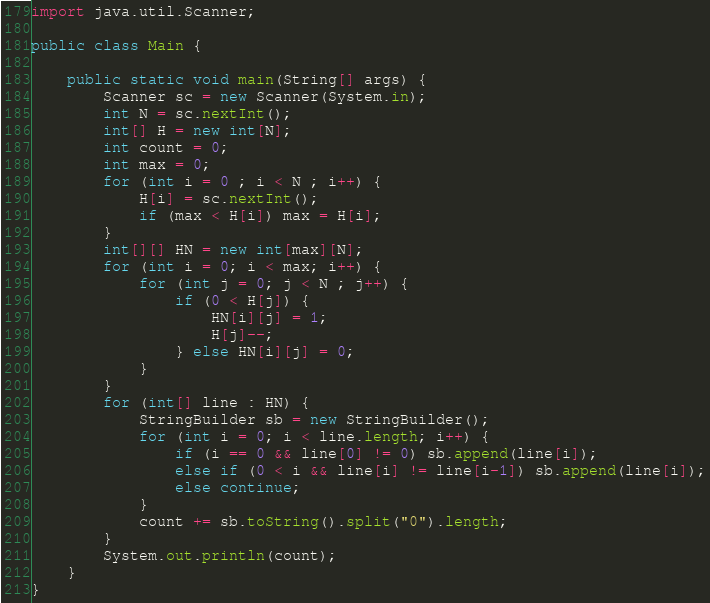<code> <loc_0><loc_0><loc_500><loc_500><_Java_>
import java.util.Scanner;

public class Main {
    
    public static void main(String[] args) {
        Scanner sc = new Scanner(System.in);
        int N = sc.nextInt();
        int[] H = new int[N];
        int count = 0;
        int max = 0;
        for (int i = 0 ; i < N ; i++) {
            H[i] = sc.nextInt();
            if (max < H[i]) max = H[i];
        }
        int[][] HN = new int[max][N];
        for (int i = 0; i < max; i++) {
            for (int j = 0; j < N ; j++) {
                if (0 < H[j]) {
                    HN[i][j] = 1;
                    H[j]--;
                } else HN[i][j] = 0;
            }
        }
        for (int[] line : HN) {
            StringBuilder sb = new StringBuilder();
            for (int i = 0; i < line.length; i++) {
                if (i == 0 && line[0] != 0) sb.append(line[i]);
                else if (0 < i && line[i] != line[i-1]) sb.append(line[i]);
                else continue;
            }
            count += sb.toString().split("0").length;
        }
        System.out.println(count);
    }
}</code> 